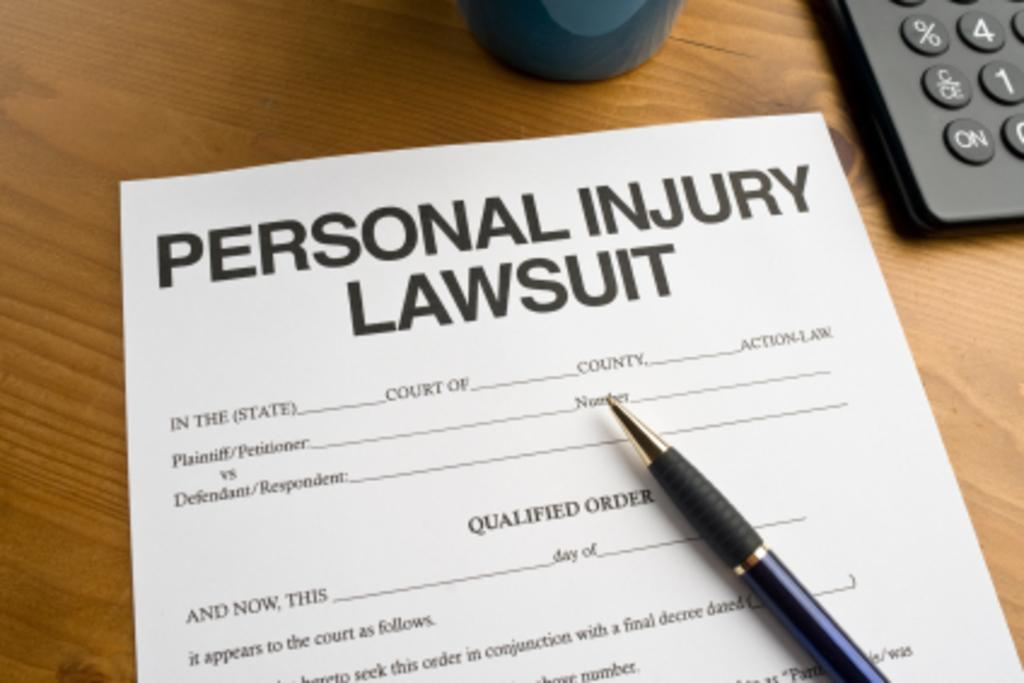<image>
Render a clear and concise summary of the photo. A form on a desk for a personal lawsuit injury with a pen laying on top of the form. 